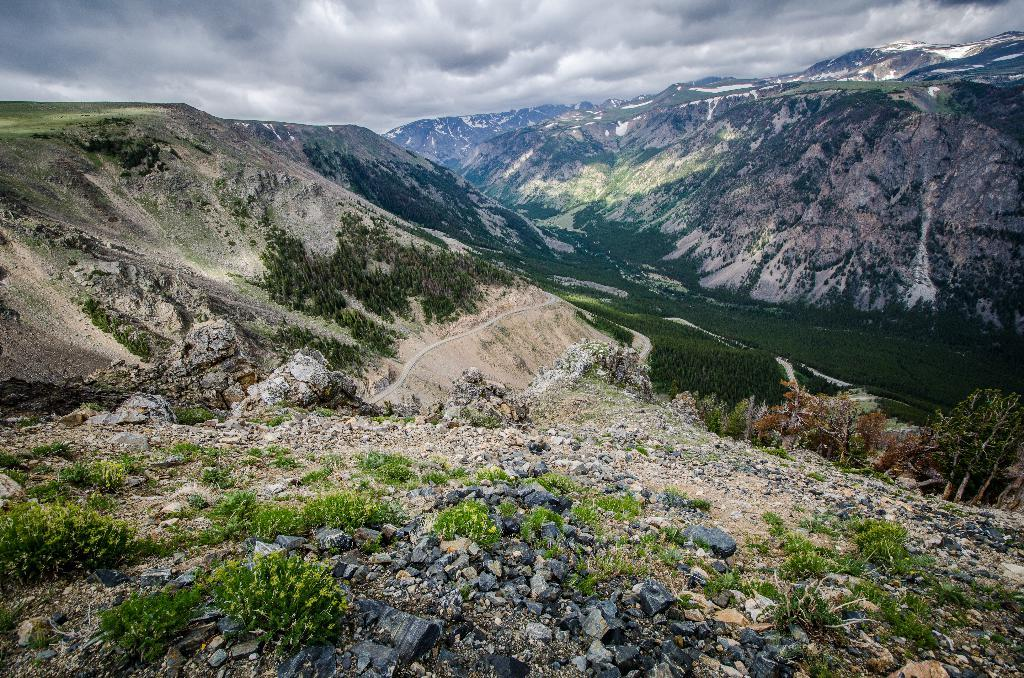What type of natural elements can be seen on the ground in the image? There are rocks and plants on the ground in the image. What can be seen in the background of the image? Hills, a road, and the sky are visible in the background of the image. What is the condition of the sky in the image? The sky is visible in the background of the image, and there are clouds present. How many sisters are holding hands in the image? There are no sisters present in the image. What type of leaf is being used as a bookmark in the image? There is no leaf or bookmark visible in the image. 